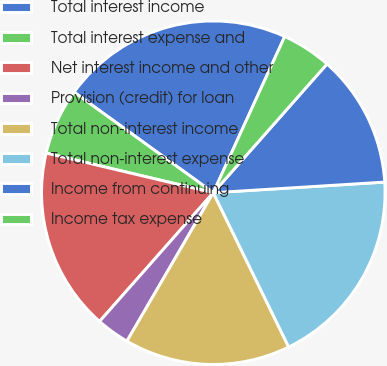Convert chart. <chart><loc_0><loc_0><loc_500><loc_500><pie_chart><fcel>Total interest income<fcel>Total interest expense and<fcel>Net interest income and other<fcel>Provision (credit) for loan<fcel>Total non-interest income<fcel>Total non-interest expense<fcel>Income from continuing<fcel>Income tax expense<nl><fcel>21.87%<fcel>6.25%<fcel>17.19%<fcel>3.13%<fcel>15.62%<fcel>18.75%<fcel>12.5%<fcel>4.69%<nl></chart> 